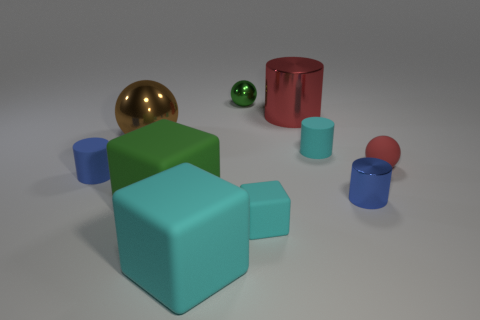Subtract all purple blocks. How many blue cylinders are left? 2 Subtract all big shiny cylinders. How many cylinders are left? 3 Subtract all cyan cylinders. How many cylinders are left? 3 Subtract 1 cubes. How many cubes are left? 2 Subtract all purple cylinders. Subtract all gray blocks. How many cylinders are left? 4 Add 5 big green things. How many big green things exist? 6 Subtract 0 green cylinders. How many objects are left? 10 Subtract all balls. How many objects are left? 7 Subtract all yellow matte things. Subtract all large cylinders. How many objects are left? 9 Add 9 blue rubber things. How many blue rubber things are left? 10 